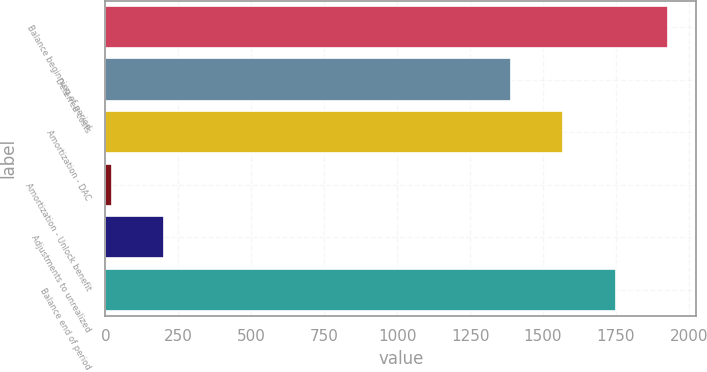Convert chart to OTSL. <chart><loc_0><loc_0><loc_500><loc_500><bar_chart><fcel>Balance beginning of period<fcel>Deferred costs<fcel>Amortization - DAC<fcel>Amortization - Unlock benefit<fcel>Adjustments to unrealized<fcel>Balance end of period<nl><fcel>1928.5<fcel>1390<fcel>1569.5<fcel>21<fcel>200.5<fcel>1749<nl></chart> 